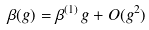Convert formula to latex. <formula><loc_0><loc_0><loc_500><loc_500>\beta ( g ) = \beta ^ { ( 1 ) } \, g + O ( g ^ { 2 } )</formula> 